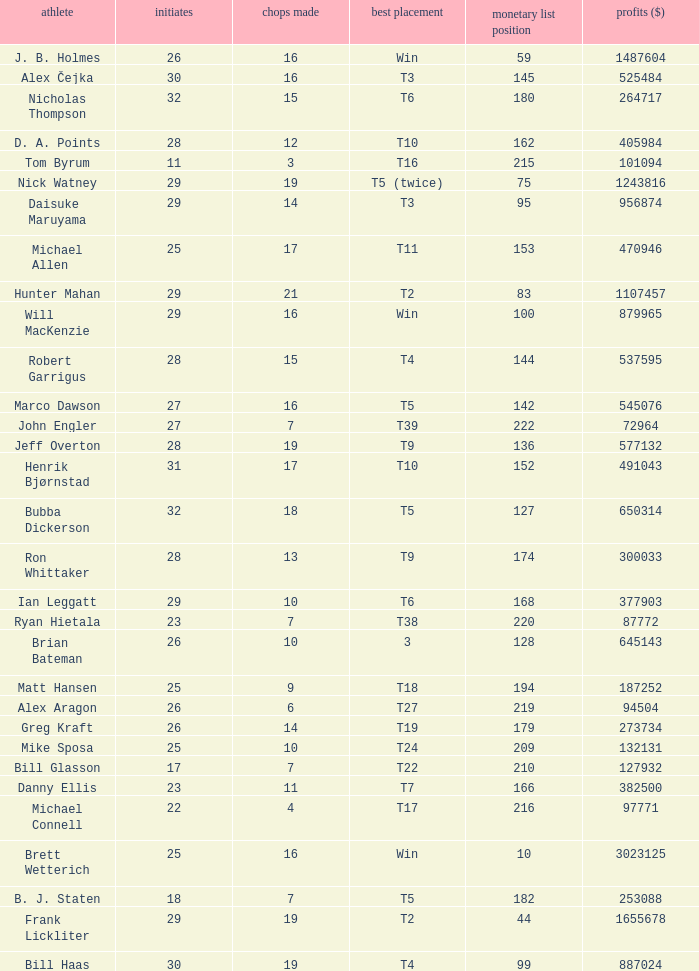What is the maximum money list rank for Matt Hansen? 194.0. Would you mind parsing the complete table? {'header': ['athlete', 'initiates', 'chops made', 'best placement', 'monetary list position', 'profits ($)'], 'rows': [['J. B. Holmes', '26', '16', 'Win', '59', '1487604'], ['Alex Čejka', '30', '16', 'T3', '145', '525484'], ['Nicholas Thompson', '32', '15', 'T6', '180', '264717'], ['D. A. Points', '28', '12', 'T10', '162', '405984'], ['Tom Byrum', '11', '3', 'T16', '215', '101094'], ['Nick Watney', '29', '19', 'T5 (twice)', '75', '1243816'], ['Daisuke Maruyama', '29', '14', 'T3', '95', '956874'], ['Michael Allen', '25', '17', 'T11', '153', '470946'], ['Hunter Mahan', '29', '21', 'T2', '83', '1107457'], ['Will MacKenzie', '29', '16', 'Win', '100', '879965'], ['Robert Garrigus', '28', '15', 'T4', '144', '537595'], ['Marco Dawson', '27', '16', 'T5', '142', '545076'], ['John Engler', '27', '7', 'T39', '222', '72964'], ['Jeff Overton', '28', '19', 'T9', '136', '577132'], ['Henrik Bjørnstad', '31', '17', 'T10', '152', '491043'], ['Bubba Dickerson', '32', '18', 'T5', '127', '650314'], ['Ron Whittaker', '28', '13', 'T9', '174', '300033'], ['Ian Leggatt', '29', '10', 'T6', '168', '377903'], ['Ryan Hietala', '23', '7', 'T38', '220', '87772'], ['Brian Bateman', '26', '10', '3', '128', '645143'], ['Matt Hansen', '25', '9', 'T18', '194', '187252'], ['Alex Aragon', '26', '6', 'T27', '219', '94504'], ['Greg Kraft', '26', '14', 'T19', '179', '273734'], ['Mike Sposa', '25', '10', 'T24', '209', '132131'], ['Bill Glasson', '17', '7', 'T22', '210', '127932'], ['Danny Ellis', '23', '11', 'T7', '166', '382500'], ['Michael Connell', '22', '4', 'T17', '216', '97771'], ['Brett Wetterich', '25', '16', 'Win', '10', '3023125'], ['B. J. Staten', '18', '7', 'T5', '182', '253088'], ['Frank Lickliter', '29', '19', 'T2', '44', '1655678'], ['Bill Haas', '30', '19', 'T4', '99', '887024']]} 